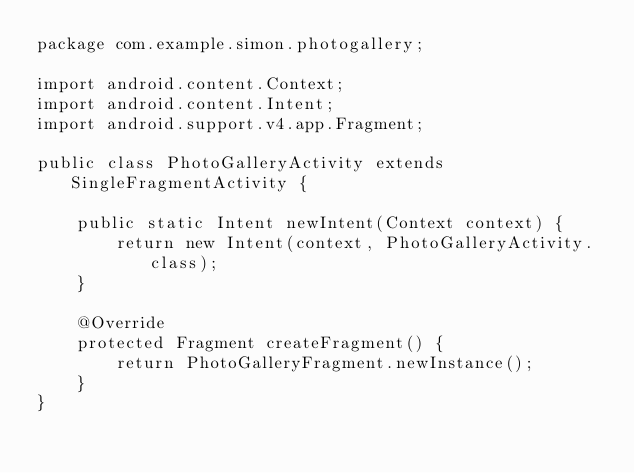Convert code to text. <code><loc_0><loc_0><loc_500><loc_500><_Java_>package com.example.simon.photogallery;

import android.content.Context;
import android.content.Intent;
import android.support.v4.app.Fragment;

public class PhotoGalleryActivity extends SingleFragmentActivity {

    public static Intent newIntent(Context context) {
        return new Intent(context, PhotoGalleryActivity.class);
    }

    @Override
    protected Fragment createFragment() {
        return PhotoGalleryFragment.newInstance();
    }
}
</code> 